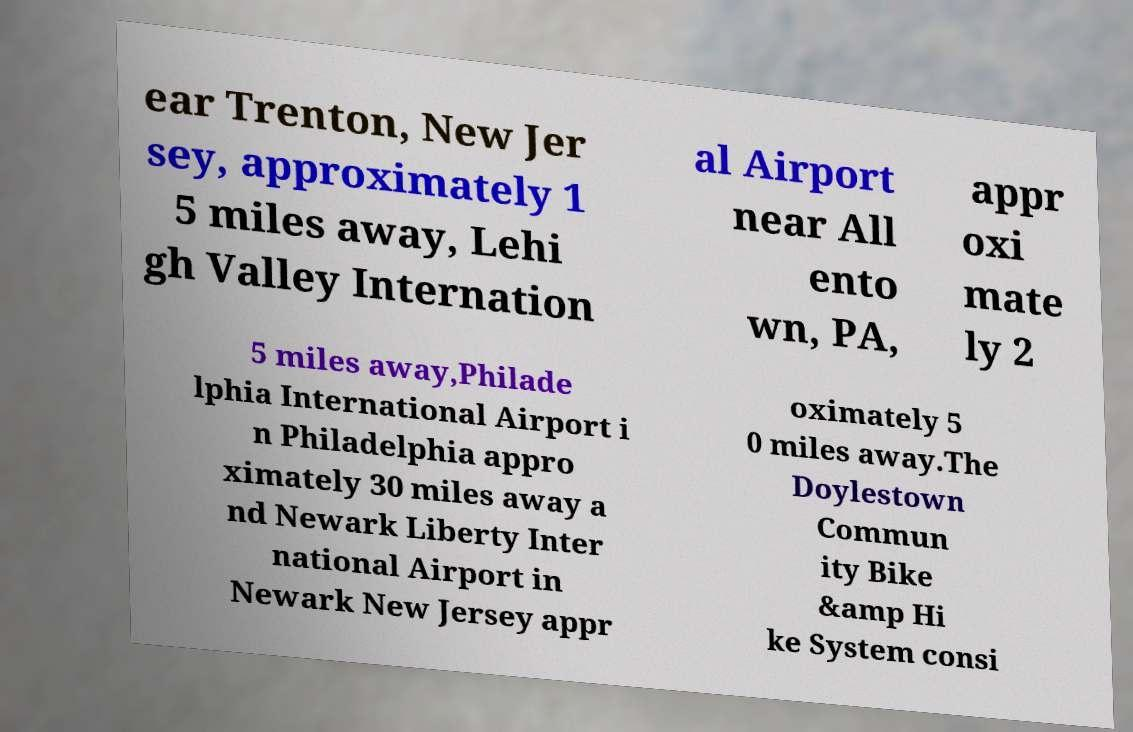There's text embedded in this image that I need extracted. Can you transcribe it verbatim? ear Trenton, New Jer sey, approximately 1 5 miles away, Lehi gh Valley Internation al Airport near All ento wn, PA, appr oxi mate ly 2 5 miles away,Philade lphia International Airport i n Philadelphia appro ximately 30 miles away a nd Newark Liberty Inter national Airport in Newark New Jersey appr oximately 5 0 miles away.The Doylestown Commun ity Bike &amp Hi ke System consi 